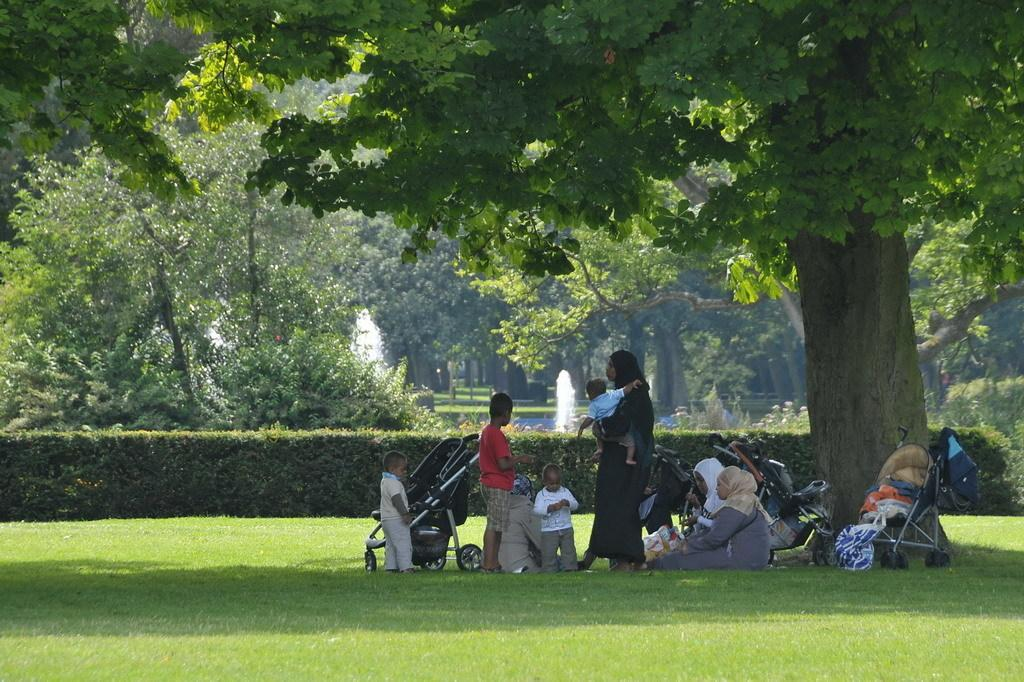Who is present in the image? There are persons in the image, including kids. What objects are associated with the kids in the image? There are strollers in the image. What type of natural environment is visible in the image? The grass, plants, and trees are visible in the image. What type of match is being played in the image? There is no match being played in the image; it does not depict any sports or games. What religious beliefs are represented in the image? There is no indication of any religious beliefs or symbols in the image. 